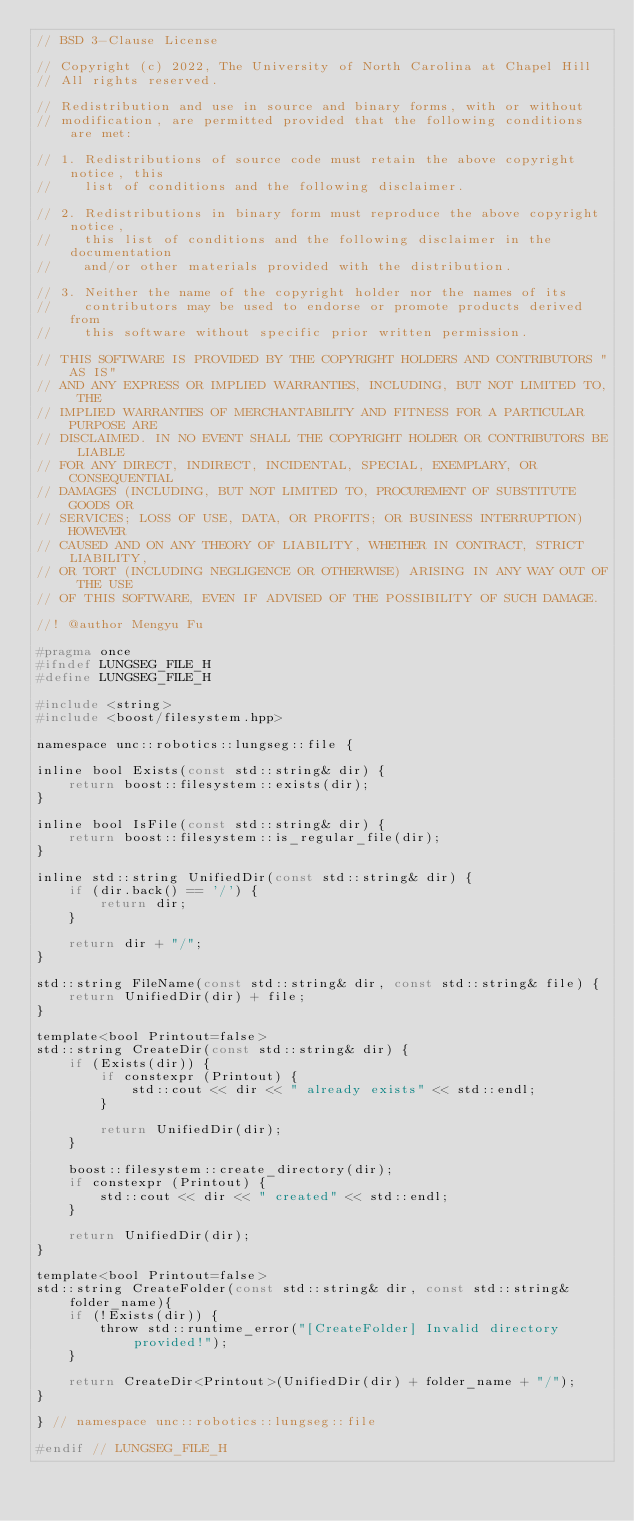<code> <loc_0><loc_0><loc_500><loc_500><_C_>// BSD 3-Clause License

// Copyright (c) 2022, The University of North Carolina at Chapel Hill
// All rights reserved.

// Redistribution and use in source and binary forms, with or without
// modification, are permitted provided that the following conditions are met:

// 1. Redistributions of source code must retain the above copyright notice, this
//    list of conditions and the following disclaimer.

// 2. Redistributions in binary form must reproduce the above copyright notice,
//    this list of conditions and the following disclaimer in the documentation
//    and/or other materials provided with the distribution.

// 3. Neither the name of the copyright holder nor the names of its
//    contributors may be used to endorse or promote products derived from
//    this software without specific prior written permission.

// THIS SOFTWARE IS PROVIDED BY THE COPYRIGHT HOLDERS AND CONTRIBUTORS "AS IS"
// AND ANY EXPRESS OR IMPLIED WARRANTIES, INCLUDING, BUT NOT LIMITED TO, THE
// IMPLIED WARRANTIES OF MERCHANTABILITY AND FITNESS FOR A PARTICULAR PURPOSE ARE
// DISCLAIMED. IN NO EVENT SHALL THE COPYRIGHT HOLDER OR CONTRIBUTORS BE LIABLE
// FOR ANY DIRECT, INDIRECT, INCIDENTAL, SPECIAL, EXEMPLARY, OR CONSEQUENTIAL
// DAMAGES (INCLUDING, BUT NOT LIMITED TO, PROCUREMENT OF SUBSTITUTE GOODS OR
// SERVICES; LOSS OF USE, DATA, OR PROFITS; OR BUSINESS INTERRUPTION) HOWEVER
// CAUSED AND ON ANY THEORY OF LIABILITY, WHETHER IN CONTRACT, STRICT LIABILITY,
// OR TORT (INCLUDING NEGLIGENCE OR OTHERWISE) ARISING IN ANY WAY OUT OF THE USE
// OF THIS SOFTWARE, EVEN IF ADVISED OF THE POSSIBILITY OF SUCH DAMAGE.

//! @author Mengyu Fu

#pragma once
#ifndef LUNGSEG_FILE_H
#define LUNGSEG_FILE_H

#include <string>
#include <boost/filesystem.hpp>

namespace unc::robotics::lungseg::file {

inline bool Exists(const std::string& dir) {
    return boost::filesystem::exists(dir);
}

inline bool IsFile(const std::string& dir) {
    return boost::filesystem::is_regular_file(dir);
}

inline std::string UnifiedDir(const std::string& dir) {
    if (dir.back() == '/') {
        return dir;
    }

    return dir + "/";
}

std::string FileName(const std::string& dir, const std::string& file) {
    return UnifiedDir(dir) + file;
}

template<bool Printout=false>
std::string CreateDir(const std::string& dir) {
    if (Exists(dir)) {
        if constexpr (Printout) {
            std::cout << dir << " already exists" << std::endl;
        }

        return UnifiedDir(dir);
    }

    boost::filesystem::create_directory(dir);
    if constexpr (Printout) {
        std::cout << dir << " created" << std::endl;
    }

    return UnifiedDir(dir);
}

template<bool Printout=false>
std::string CreateFolder(const std::string& dir, const std::string& folder_name){
    if (!Exists(dir)) {
        throw std::runtime_error("[CreateFolder] Invalid directory provided!");
    }

    return CreateDir<Printout>(UnifiedDir(dir) + folder_name + "/");
}

} // namespace unc::robotics::lungseg::file

#endif // LUNGSEG_FILE_H</code> 